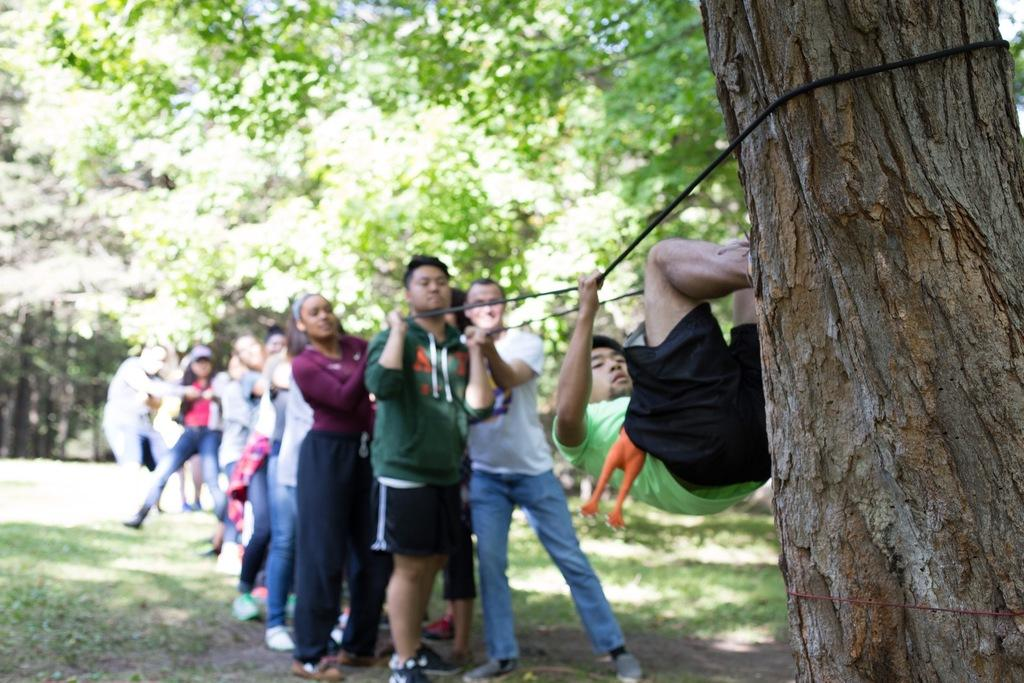Who or what is present in the image? There are people in the image. What are the people doing in the image? The people are holding a rope. What can be seen in the background of the image? There are trees in the background of the image. What type of cough medicine is visible in the image? There is no cough medicine present in the image. What kind of space-related objects can be seen in the image? There are no space-related objects present in the image. 